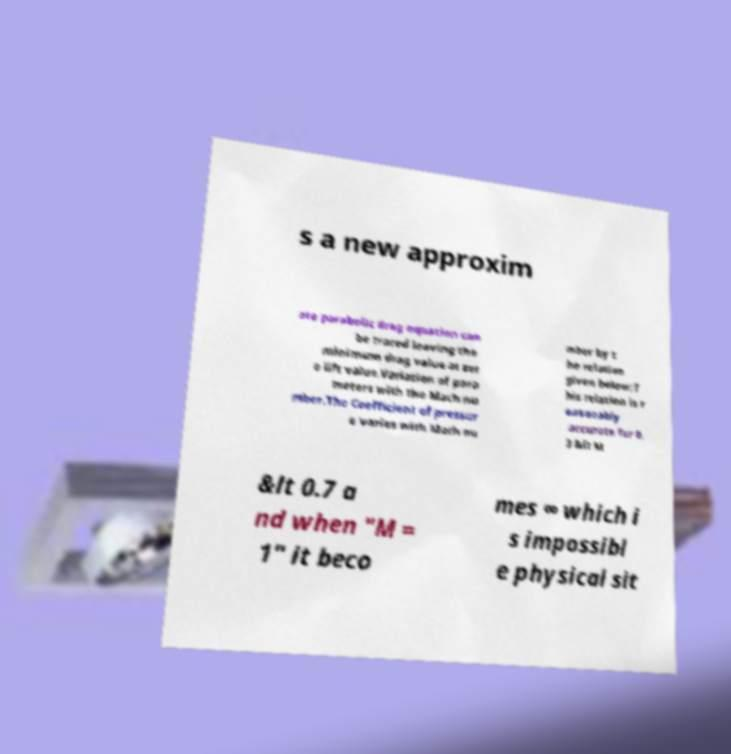For documentation purposes, I need the text within this image transcribed. Could you provide that? s a new approxim ate parabolic drag equation can be traced leaving the minimum drag value at zer o lift value.Variation of para meters with the Mach nu mber.The Coefficient of pressur e varies with Mach nu mber by t he relation given below:T his relation is r easonably accurate for 0. 3 &lt M &lt 0.7 a nd when "M = 1" it beco mes ∞ which i s impossibl e physical sit 